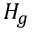Convert formula to latex. <formula><loc_0><loc_0><loc_500><loc_500>H _ { g }</formula> 